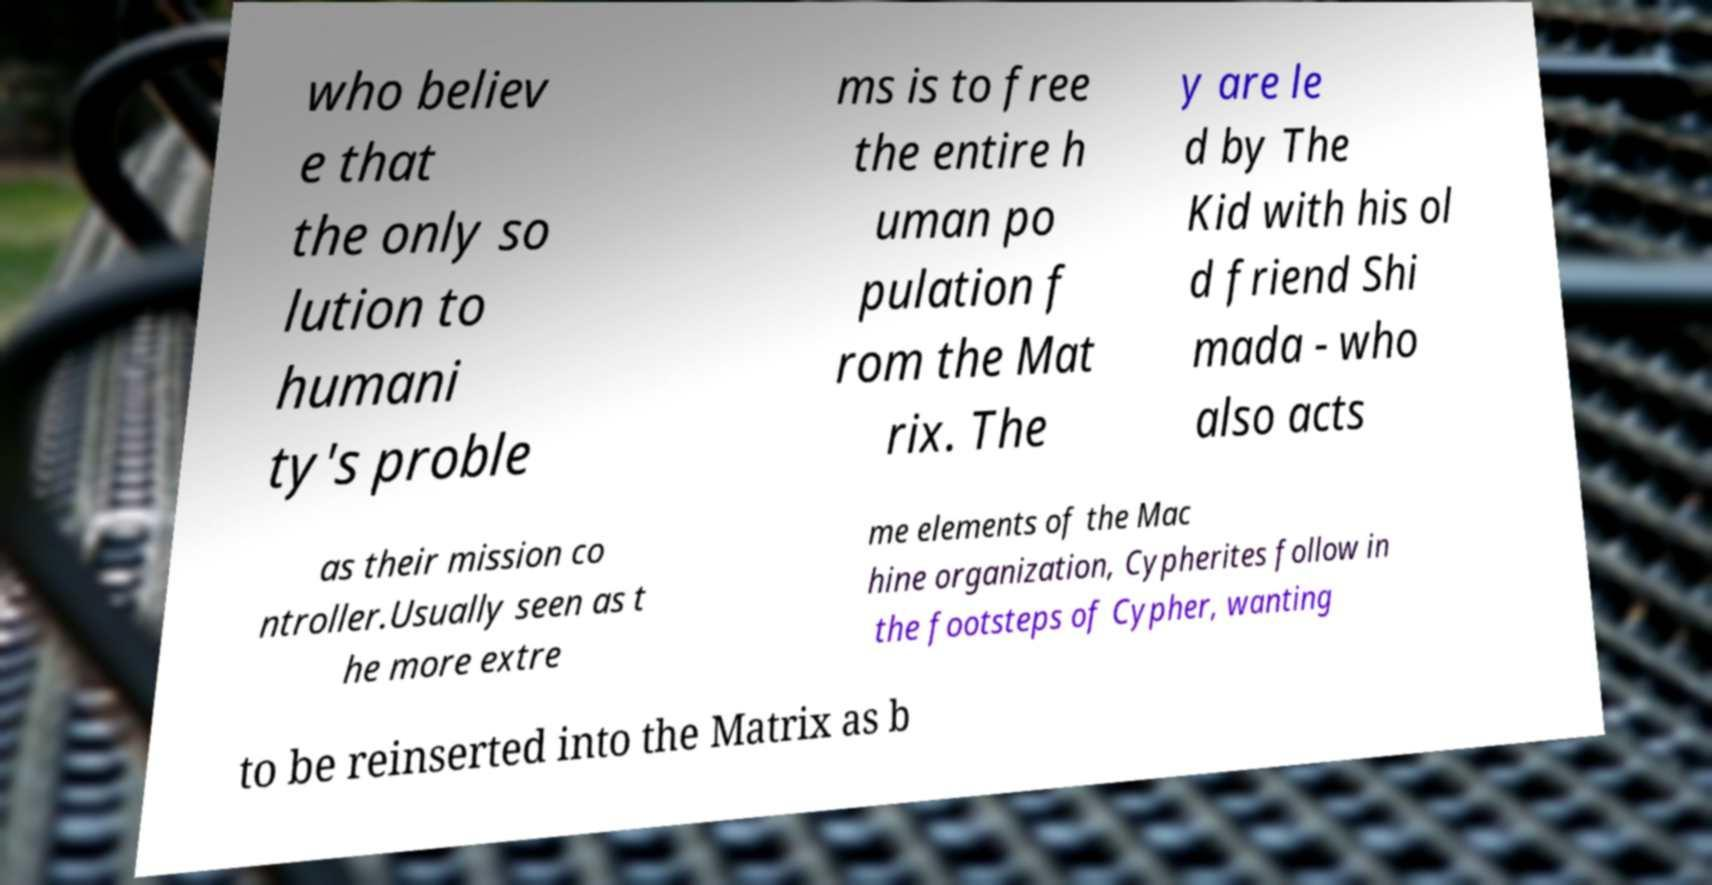Could you assist in decoding the text presented in this image and type it out clearly? who believ e that the only so lution to humani ty's proble ms is to free the entire h uman po pulation f rom the Mat rix. The y are le d by The Kid with his ol d friend Shi mada - who also acts as their mission co ntroller.Usually seen as t he more extre me elements of the Mac hine organization, Cypherites follow in the footsteps of Cypher, wanting to be reinserted into the Matrix as b 